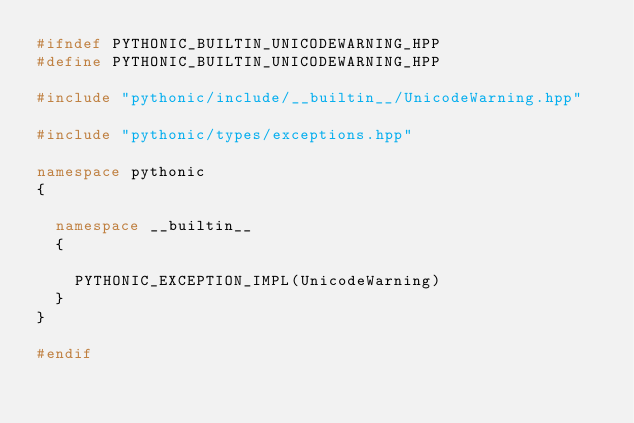Convert code to text. <code><loc_0><loc_0><loc_500><loc_500><_C++_>#ifndef PYTHONIC_BUILTIN_UNICODEWARNING_HPP
#define PYTHONIC_BUILTIN_UNICODEWARNING_HPP

#include "pythonic/include/__builtin__/UnicodeWarning.hpp"

#include "pythonic/types/exceptions.hpp"

namespace pythonic
{

  namespace __builtin__
  {

    PYTHONIC_EXCEPTION_IMPL(UnicodeWarning)
  }
}

#endif
</code> 